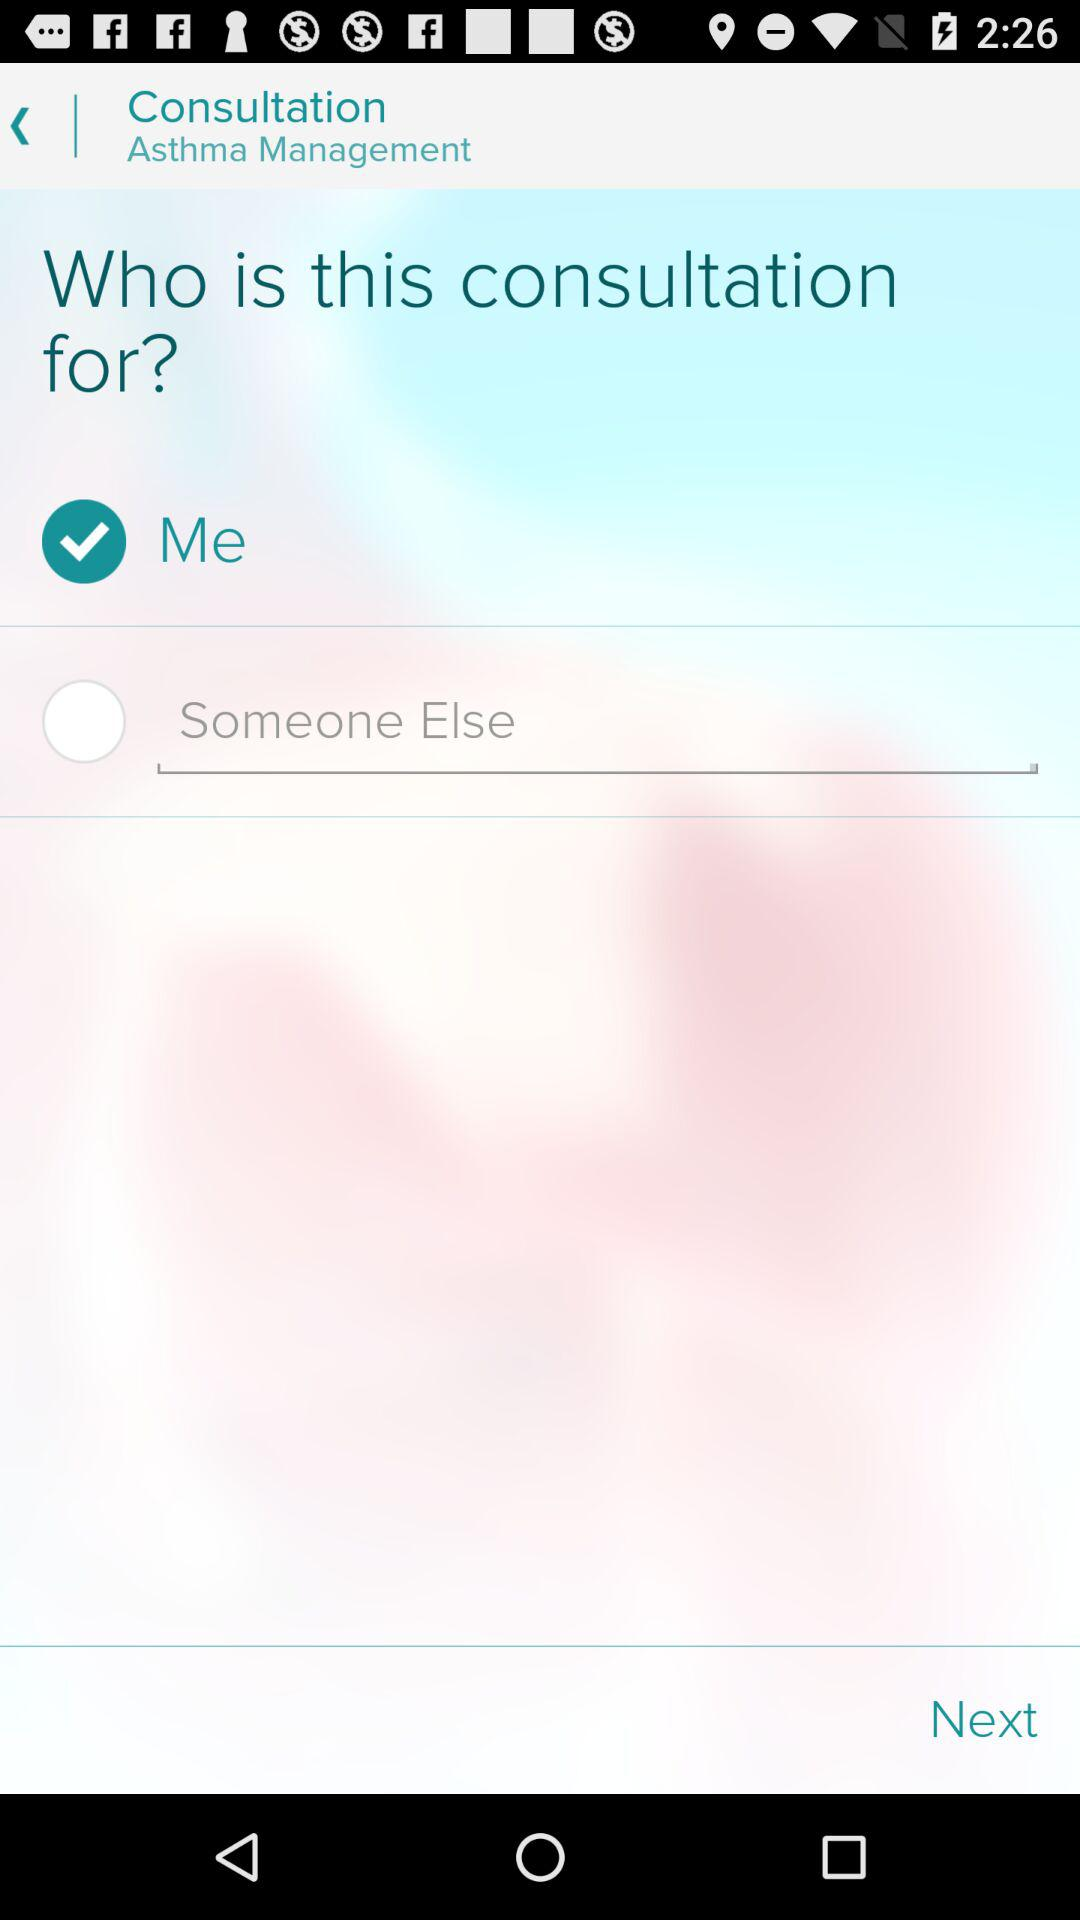How many ways can I select the consultation for?
Answer the question using a single word or phrase. 2 